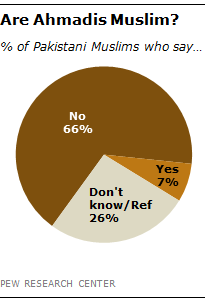Give some essential details in this illustration. The smallest two segments of the graph have a difference in value of 19. The biggest segment of the graph is predominantly dark brown in color. 